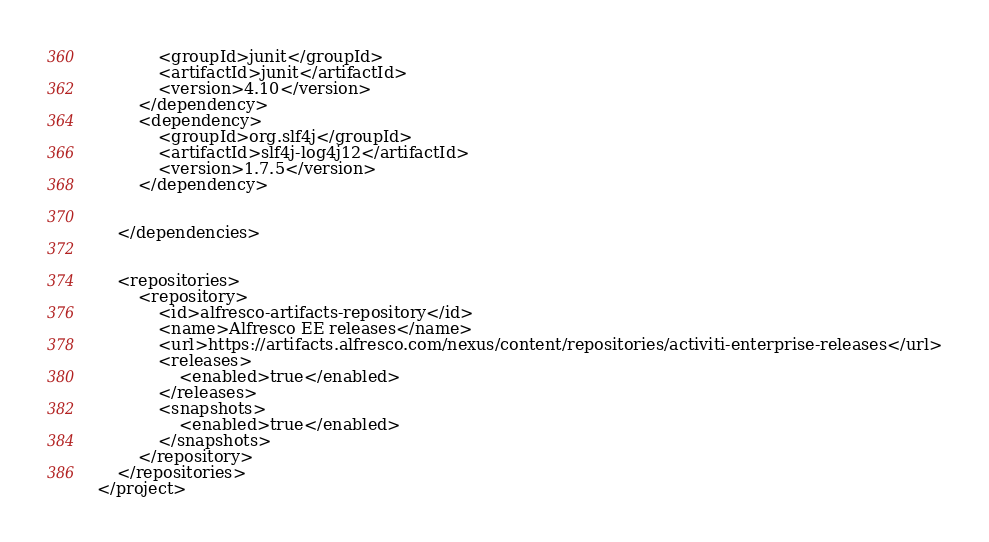Convert code to text. <code><loc_0><loc_0><loc_500><loc_500><_XML_>			<groupId>junit</groupId>
			<artifactId>junit</artifactId>
			<version>4.10</version>
		</dependency>
		<dependency>
			<groupId>org.slf4j</groupId>
			<artifactId>slf4j-log4j12</artifactId>
			<version>1.7.5</version>
		</dependency>


	</dependencies>
	
	
	<repositories>
		<repository>
			<id>alfresco-artifacts-repository</id>
			<name>Alfresco EE releases</name>
			<url>https://artifacts.alfresco.com/nexus/content/repositories/activiti-enterprise-releases</url>
			<releases>
				<enabled>true</enabled>
			</releases>
			<snapshots>
				<enabled>true</enabled>
			</snapshots>
		</repository>
	</repositories>
</project></code> 